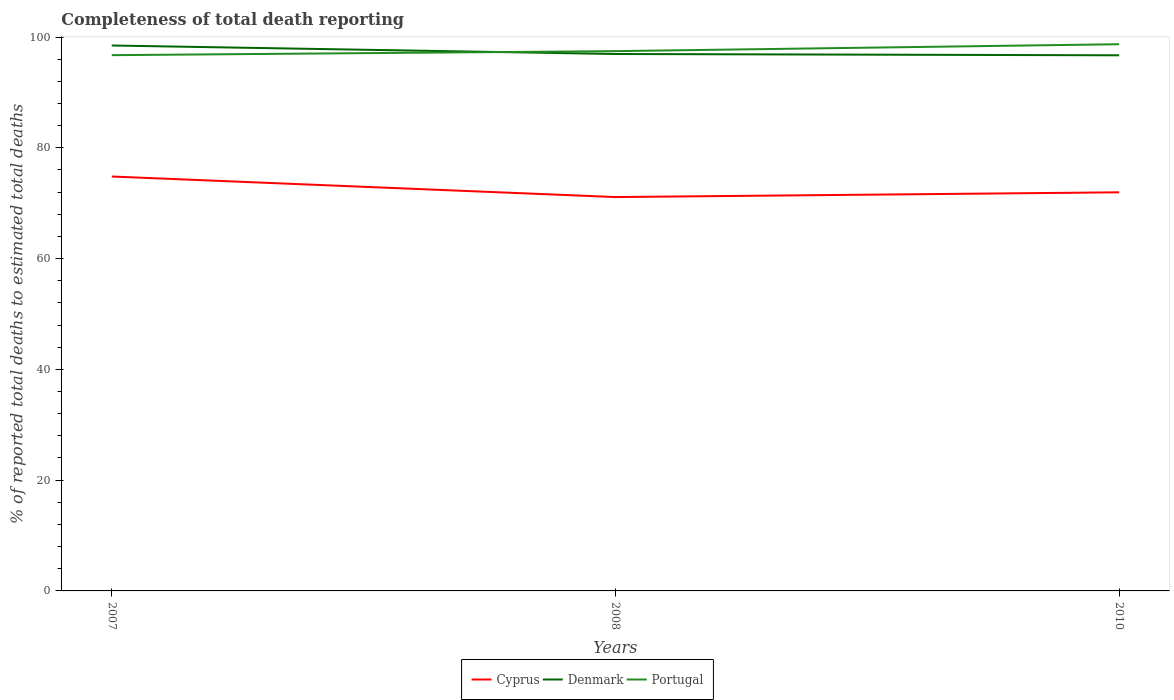Does the line corresponding to Portugal intersect with the line corresponding to Denmark?
Your answer should be compact. Yes. Across all years, what is the maximum percentage of total deaths reported in Cyprus?
Give a very brief answer. 71.11. What is the total percentage of total deaths reported in Cyprus in the graph?
Ensure brevity in your answer.  -0.86. What is the difference between the highest and the second highest percentage of total deaths reported in Cyprus?
Ensure brevity in your answer.  3.71. How many lines are there?
Ensure brevity in your answer.  3. How many years are there in the graph?
Offer a very short reply. 3. What is the difference between two consecutive major ticks on the Y-axis?
Your response must be concise. 20. Are the values on the major ticks of Y-axis written in scientific E-notation?
Your answer should be very brief. No. Where does the legend appear in the graph?
Provide a succinct answer. Bottom center. How many legend labels are there?
Give a very brief answer. 3. What is the title of the graph?
Your response must be concise. Completeness of total death reporting. Does "Morocco" appear as one of the legend labels in the graph?
Give a very brief answer. No. What is the label or title of the X-axis?
Your answer should be compact. Years. What is the label or title of the Y-axis?
Ensure brevity in your answer.  % of reported total deaths to estimated total deaths. What is the % of reported total deaths to estimated total deaths of Cyprus in 2007?
Your answer should be compact. 74.82. What is the % of reported total deaths to estimated total deaths of Denmark in 2007?
Keep it short and to the point. 98.48. What is the % of reported total deaths to estimated total deaths in Portugal in 2007?
Ensure brevity in your answer.  96.74. What is the % of reported total deaths to estimated total deaths in Cyprus in 2008?
Offer a terse response. 71.11. What is the % of reported total deaths to estimated total deaths in Denmark in 2008?
Provide a short and direct response. 96.94. What is the % of reported total deaths to estimated total deaths of Portugal in 2008?
Your answer should be compact. 97.46. What is the % of reported total deaths to estimated total deaths of Cyprus in 2010?
Offer a terse response. 71.97. What is the % of reported total deaths to estimated total deaths in Denmark in 2010?
Ensure brevity in your answer.  96.71. What is the % of reported total deaths to estimated total deaths in Portugal in 2010?
Provide a succinct answer. 98.71. Across all years, what is the maximum % of reported total deaths to estimated total deaths in Cyprus?
Your response must be concise. 74.82. Across all years, what is the maximum % of reported total deaths to estimated total deaths of Denmark?
Your answer should be very brief. 98.48. Across all years, what is the maximum % of reported total deaths to estimated total deaths in Portugal?
Ensure brevity in your answer.  98.71. Across all years, what is the minimum % of reported total deaths to estimated total deaths in Cyprus?
Your answer should be very brief. 71.11. Across all years, what is the minimum % of reported total deaths to estimated total deaths in Denmark?
Offer a very short reply. 96.71. Across all years, what is the minimum % of reported total deaths to estimated total deaths in Portugal?
Provide a short and direct response. 96.74. What is the total % of reported total deaths to estimated total deaths of Cyprus in the graph?
Your answer should be very brief. 217.9. What is the total % of reported total deaths to estimated total deaths of Denmark in the graph?
Provide a succinct answer. 292.13. What is the total % of reported total deaths to estimated total deaths in Portugal in the graph?
Your answer should be very brief. 292.9. What is the difference between the % of reported total deaths to estimated total deaths of Cyprus in 2007 and that in 2008?
Provide a succinct answer. 3.71. What is the difference between the % of reported total deaths to estimated total deaths in Denmark in 2007 and that in 2008?
Your response must be concise. 1.53. What is the difference between the % of reported total deaths to estimated total deaths of Portugal in 2007 and that in 2008?
Ensure brevity in your answer.  -0.72. What is the difference between the % of reported total deaths to estimated total deaths of Cyprus in 2007 and that in 2010?
Give a very brief answer. 2.85. What is the difference between the % of reported total deaths to estimated total deaths in Denmark in 2007 and that in 2010?
Keep it short and to the point. 1.77. What is the difference between the % of reported total deaths to estimated total deaths of Portugal in 2007 and that in 2010?
Your answer should be very brief. -1.97. What is the difference between the % of reported total deaths to estimated total deaths in Cyprus in 2008 and that in 2010?
Provide a short and direct response. -0.86. What is the difference between the % of reported total deaths to estimated total deaths in Denmark in 2008 and that in 2010?
Give a very brief answer. 0.23. What is the difference between the % of reported total deaths to estimated total deaths in Portugal in 2008 and that in 2010?
Make the answer very short. -1.25. What is the difference between the % of reported total deaths to estimated total deaths of Cyprus in 2007 and the % of reported total deaths to estimated total deaths of Denmark in 2008?
Give a very brief answer. -22.12. What is the difference between the % of reported total deaths to estimated total deaths of Cyprus in 2007 and the % of reported total deaths to estimated total deaths of Portugal in 2008?
Provide a short and direct response. -22.64. What is the difference between the % of reported total deaths to estimated total deaths of Denmark in 2007 and the % of reported total deaths to estimated total deaths of Portugal in 2008?
Your answer should be compact. 1.02. What is the difference between the % of reported total deaths to estimated total deaths of Cyprus in 2007 and the % of reported total deaths to estimated total deaths of Denmark in 2010?
Your answer should be very brief. -21.89. What is the difference between the % of reported total deaths to estimated total deaths of Cyprus in 2007 and the % of reported total deaths to estimated total deaths of Portugal in 2010?
Give a very brief answer. -23.89. What is the difference between the % of reported total deaths to estimated total deaths in Denmark in 2007 and the % of reported total deaths to estimated total deaths in Portugal in 2010?
Provide a short and direct response. -0.23. What is the difference between the % of reported total deaths to estimated total deaths in Cyprus in 2008 and the % of reported total deaths to estimated total deaths in Denmark in 2010?
Provide a succinct answer. -25.6. What is the difference between the % of reported total deaths to estimated total deaths in Cyprus in 2008 and the % of reported total deaths to estimated total deaths in Portugal in 2010?
Your answer should be compact. -27.6. What is the difference between the % of reported total deaths to estimated total deaths in Denmark in 2008 and the % of reported total deaths to estimated total deaths in Portugal in 2010?
Provide a succinct answer. -1.77. What is the average % of reported total deaths to estimated total deaths in Cyprus per year?
Give a very brief answer. 72.64. What is the average % of reported total deaths to estimated total deaths in Denmark per year?
Offer a terse response. 97.38. What is the average % of reported total deaths to estimated total deaths in Portugal per year?
Keep it short and to the point. 97.63. In the year 2007, what is the difference between the % of reported total deaths to estimated total deaths in Cyprus and % of reported total deaths to estimated total deaths in Denmark?
Provide a succinct answer. -23.65. In the year 2007, what is the difference between the % of reported total deaths to estimated total deaths of Cyprus and % of reported total deaths to estimated total deaths of Portugal?
Keep it short and to the point. -21.91. In the year 2007, what is the difference between the % of reported total deaths to estimated total deaths of Denmark and % of reported total deaths to estimated total deaths of Portugal?
Make the answer very short. 1.74. In the year 2008, what is the difference between the % of reported total deaths to estimated total deaths in Cyprus and % of reported total deaths to estimated total deaths in Denmark?
Keep it short and to the point. -25.83. In the year 2008, what is the difference between the % of reported total deaths to estimated total deaths of Cyprus and % of reported total deaths to estimated total deaths of Portugal?
Ensure brevity in your answer.  -26.35. In the year 2008, what is the difference between the % of reported total deaths to estimated total deaths of Denmark and % of reported total deaths to estimated total deaths of Portugal?
Make the answer very short. -0.52. In the year 2010, what is the difference between the % of reported total deaths to estimated total deaths in Cyprus and % of reported total deaths to estimated total deaths in Denmark?
Your answer should be compact. -24.74. In the year 2010, what is the difference between the % of reported total deaths to estimated total deaths of Cyprus and % of reported total deaths to estimated total deaths of Portugal?
Keep it short and to the point. -26.74. In the year 2010, what is the difference between the % of reported total deaths to estimated total deaths in Denmark and % of reported total deaths to estimated total deaths in Portugal?
Ensure brevity in your answer.  -2. What is the ratio of the % of reported total deaths to estimated total deaths in Cyprus in 2007 to that in 2008?
Offer a terse response. 1.05. What is the ratio of the % of reported total deaths to estimated total deaths of Denmark in 2007 to that in 2008?
Your answer should be very brief. 1.02. What is the ratio of the % of reported total deaths to estimated total deaths of Portugal in 2007 to that in 2008?
Give a very brief answer. 0.99. What is the ratio of the % of reported total deaths to estimated total deaths in Cyprus in 2007 to that in 2010?
Make the answer very short. 1.04. What is the ratio of the % of reported total deaths to estimated total deaths in Denmark in 2007 to that in 2010?
Offer a very short reply. 1.02. What is the ratio of the % of reported total deaths to estimated total deaths of Denmark in 2008 to that in 2010?
Offer a very short reply. 1. What is the ratio of the % of reported total deaths to estimated total deaths of Portugal in 2008 to that in 2010?
Your response must be concise. 0.99. What is the difference between the highest and the second highest % of reported total deaths to estimated total deaths in Cyprus?
Your answer should be compact. 2.85. What is the difference between the highest and the second highest % of reported total deaths to estimated total deaths of Denmark?
Your response must be concise. 1.53. What is the difference between the highest and the second highest % of reported total deaths to estimated total deaths of Portugal?
Give a very brief answer. 1.25. What is the difference between the highest and the lowest % of reported total deaths to estimated total deaths in Cyprus?
Provide a succinct answer. 3.71. What is the difference between the highest and the lowest % of reported total deaths to estimated total deaths of Denmark?
Your response must be concise. 1.77. What is the difference between the highest and the lowest % of reported total deaths to estimated total deaths of Portugal?
Offer a very short reply. 1.97. 